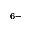Convert formula to latex. <formula><loc_0><loc_0><loc_500><loc_500>^ { 6 - }</formula> 